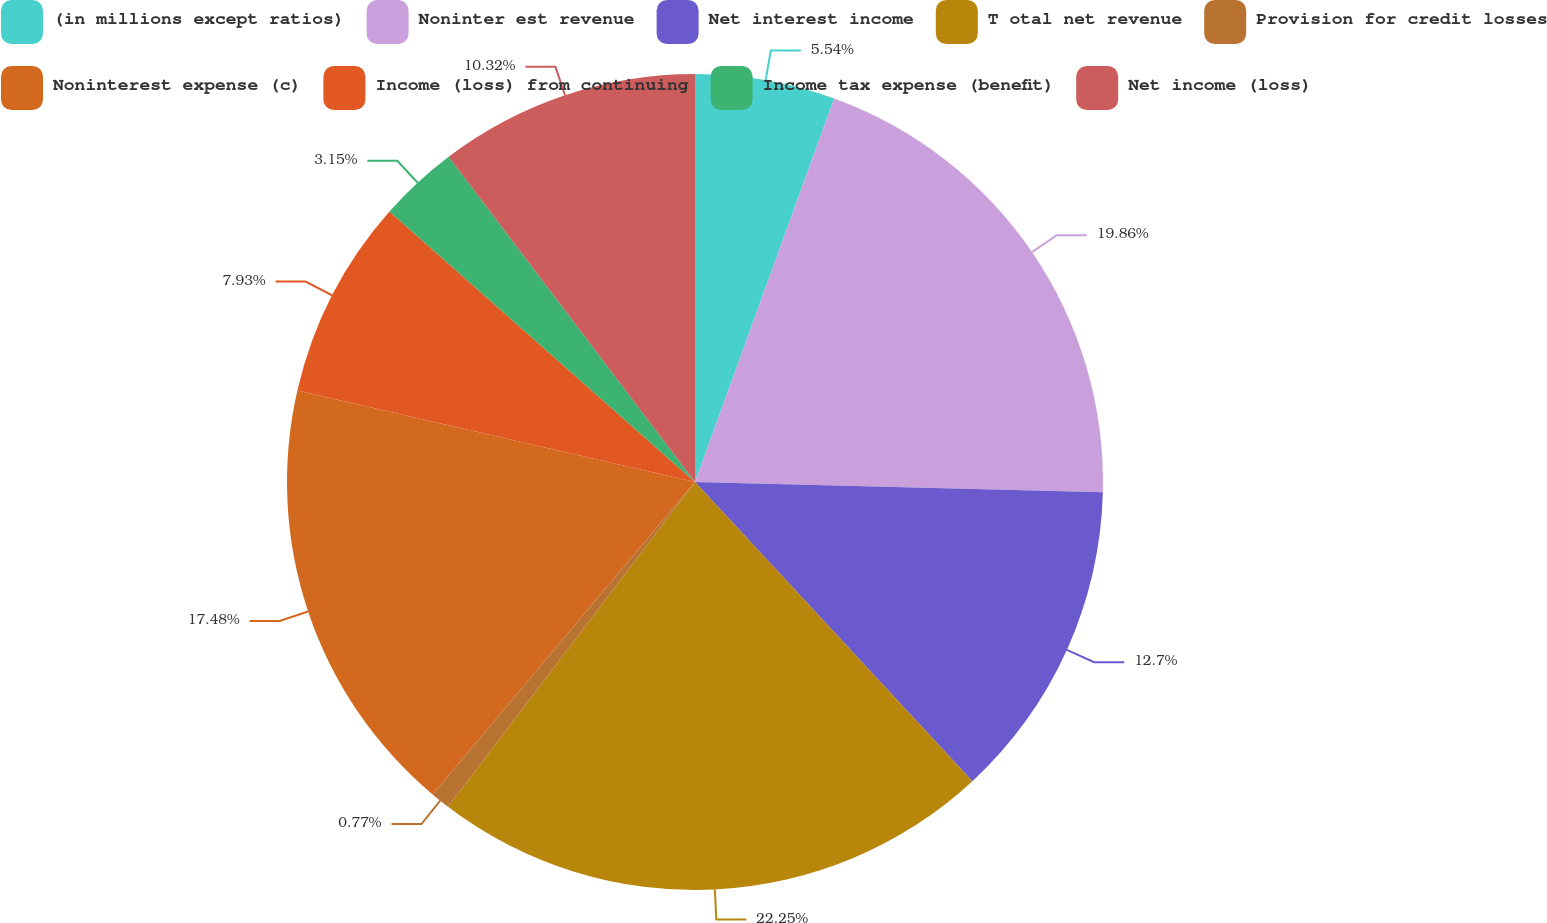Convert chart. <chart><loc_0><loc_0><loc_500><loc_500><pie_chart><fcel>(in millions except ratios)<fcel>Noninter est revenue<fcel>Net interest income<fcel>T otal net revenue<fcel>Provision for credit losses<fcel>Noninterest expense (c)<fcel>Income (loss) from continuing<fcel>Income tax expense (benefit)<fcel>Net income (loss)<nl><fcel>5.54%<fcel>19.86%<fcel>12.7%<fcel>22.25%<fcel>0.77%<fcel>17.48%<fcel>7.93%<fcel>3.15%<fcel>10.32%<nl></chart> 